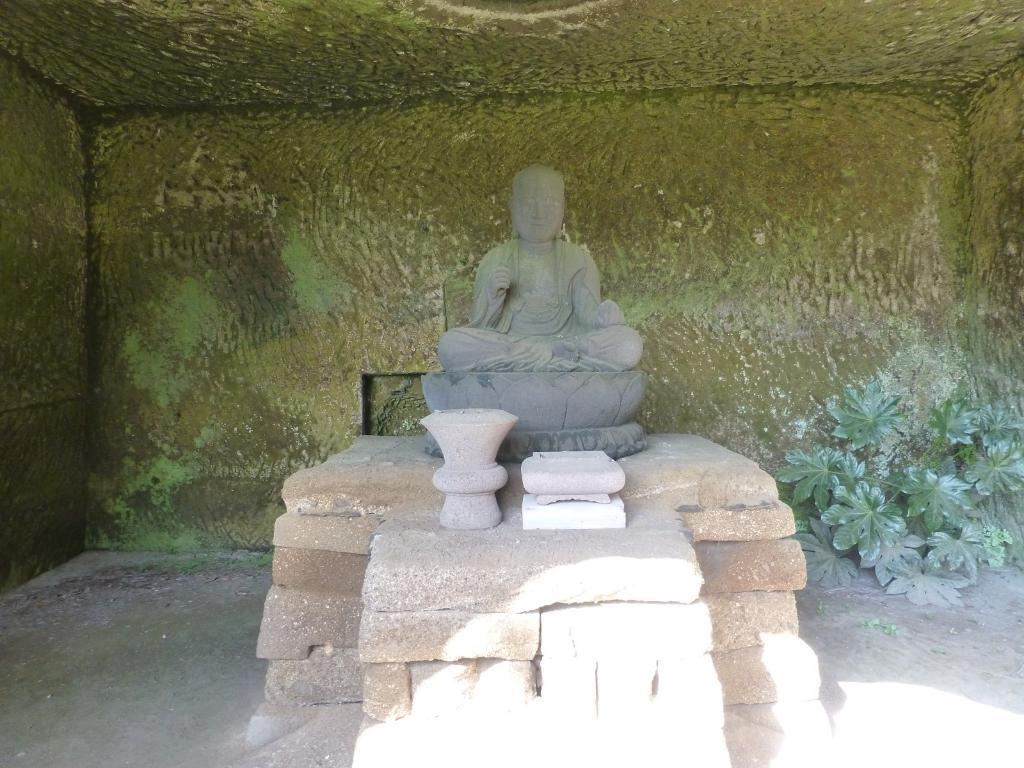What is the main subject in the image? There is a statue in the image. What is the color of the statue? The statue is grey in color. What type of structure can be seen in the image? There is a brick wall in the image. What is the color of the background in the image? The background of the image is green. What type of vegetation is visible in the image? There is a small plant visible in the image. What type of government is depicted in the statue in the image? The image does not depict any government or political figures; it only features a statue. How does the statue crush the small plant in the image? The statue does not crush the small plant in the image; they are separate elements in the scene. 